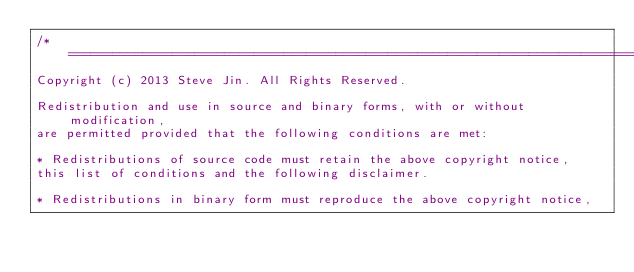<code> <loc_0><loc_0><loc_500><loc_500><_Java_>/*================================================================================
Copyright (c) 2013 Steve Jin. All Rights Reserved.

Redistribution and use in source and binary forms, with or without modification, 
are permitted provided that the following conditions are met:

* Redistributions of source code must retain the above copyright notice, 
this list of conditions and the following disclaimer.

* Redistributions in binary form must reproduce the above copyright notice, </code> 